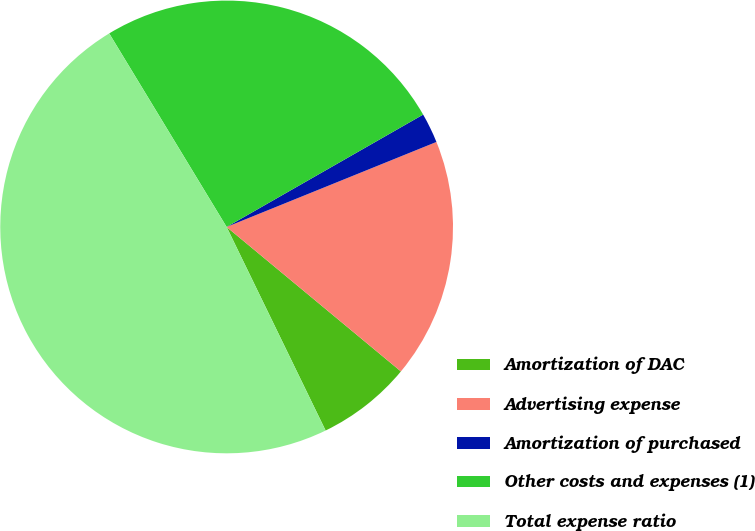<chart> <loc_0><loc_0><loc_500><loc_500><pie_chart><fcel>Amortization of DAC<fcel>Advertising expense<fcel>Amortization of purchased<fcel>Other costs and expenses (1)<fcel>Total expense ratio<nl><fcel>6.78%<fcel>17.14%<fcel>2.14%<fcel>25.41%<fcel>48.52%<nl></chart> 